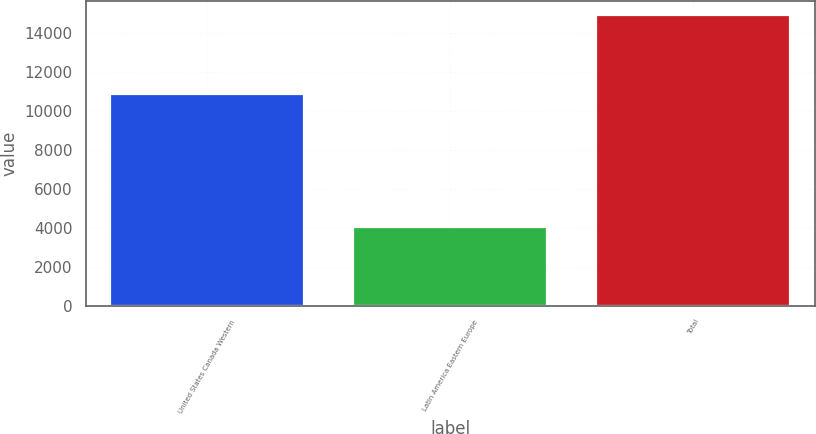Convert chart. <chart><loc_0><loc_0><loc_500><loc_500><bar_chart><fcel>United States Canada Western<fcel>Latin America Eastern Europe<fcel>Total<nl><fcel>10844<fcel>4041<fcel>14885<nl></chart> 